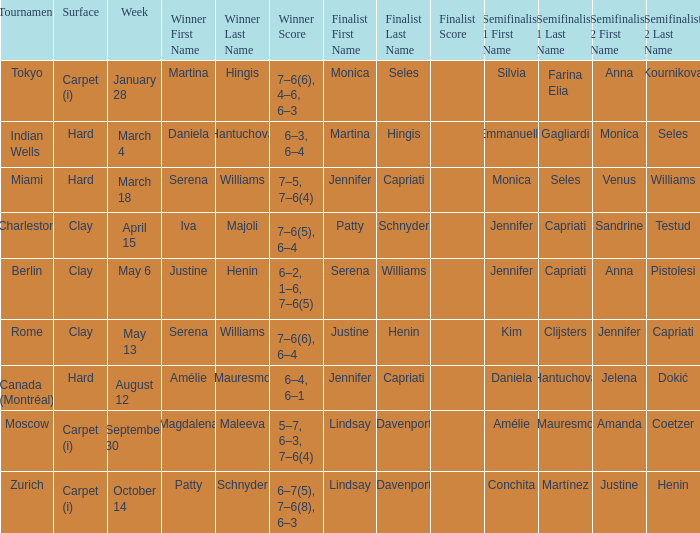Who was the winner in the Indian Wells? Daniela Hantuchová 6–3, 6–4. 